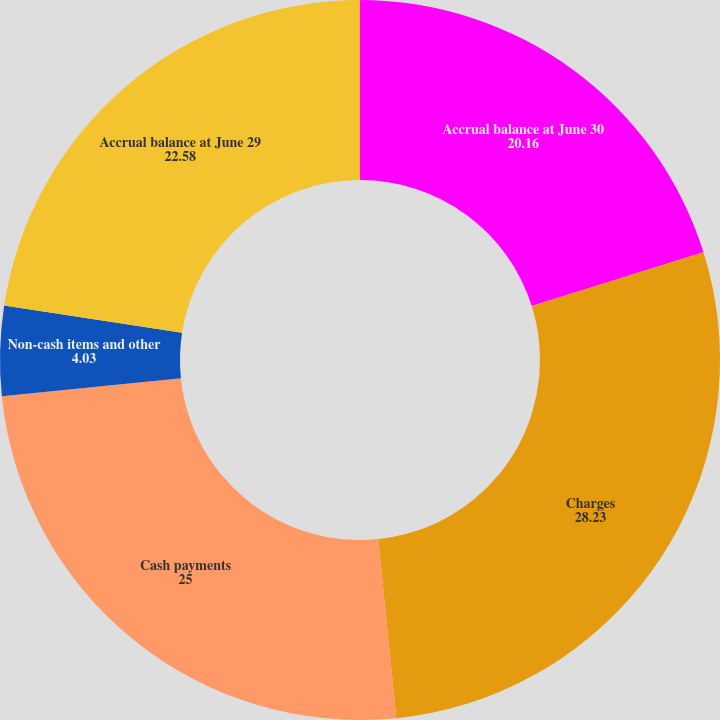Convert chart to OTSL. <chart><loc_0><loc_0><loc_500><loc_500><pie_chart><fcel>Accrual balance at June 30<fcel>Charges<fcel>Cash payments<fcel>Non-cash items and other<fcel>Accrual balance at June 29<nl><fcel>20.16%<fcel>28.23%<fcel>25.0%<fcel>4.03%<fcel>22.58%<nl></chart> 